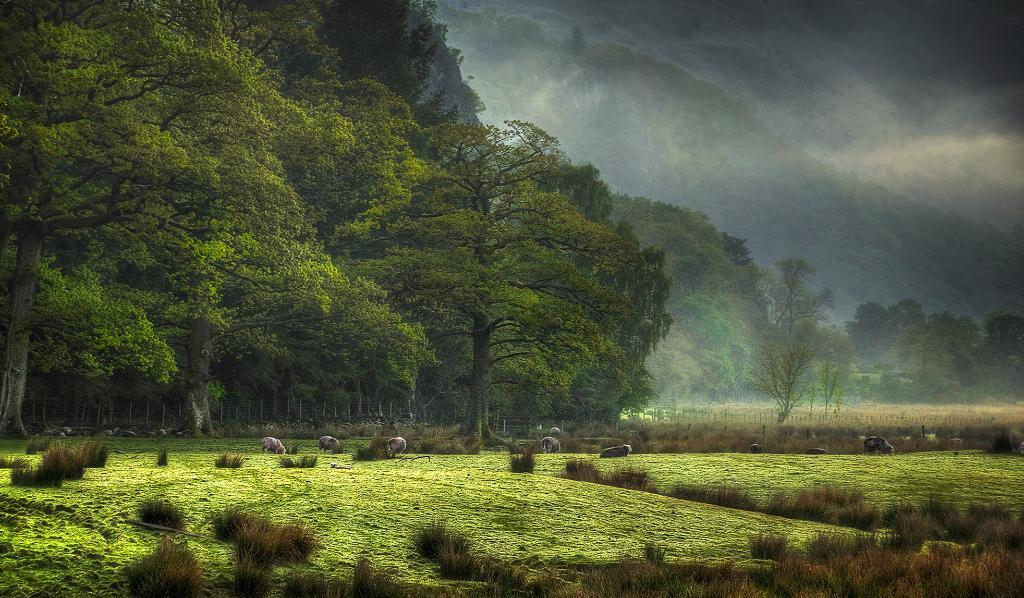What type of vegetation is present in the image? There are trees in the image. What other living organisms can be seen in the image? There are animals in the image. What is at the bottom of the image? There is grass at the bottom of the image. What can be seen in the distance in the image? There are hills in the background of the image. What is visible in the sky in the image? The sky is visible in the background of the image. Can you tell me how many babies are crawling on the trail in the image? There is no trail or babies present in the image. What type of curve can be seen in the image? There is no curve visible in the image; it features trees, animals, grass, hills, and the sky. 